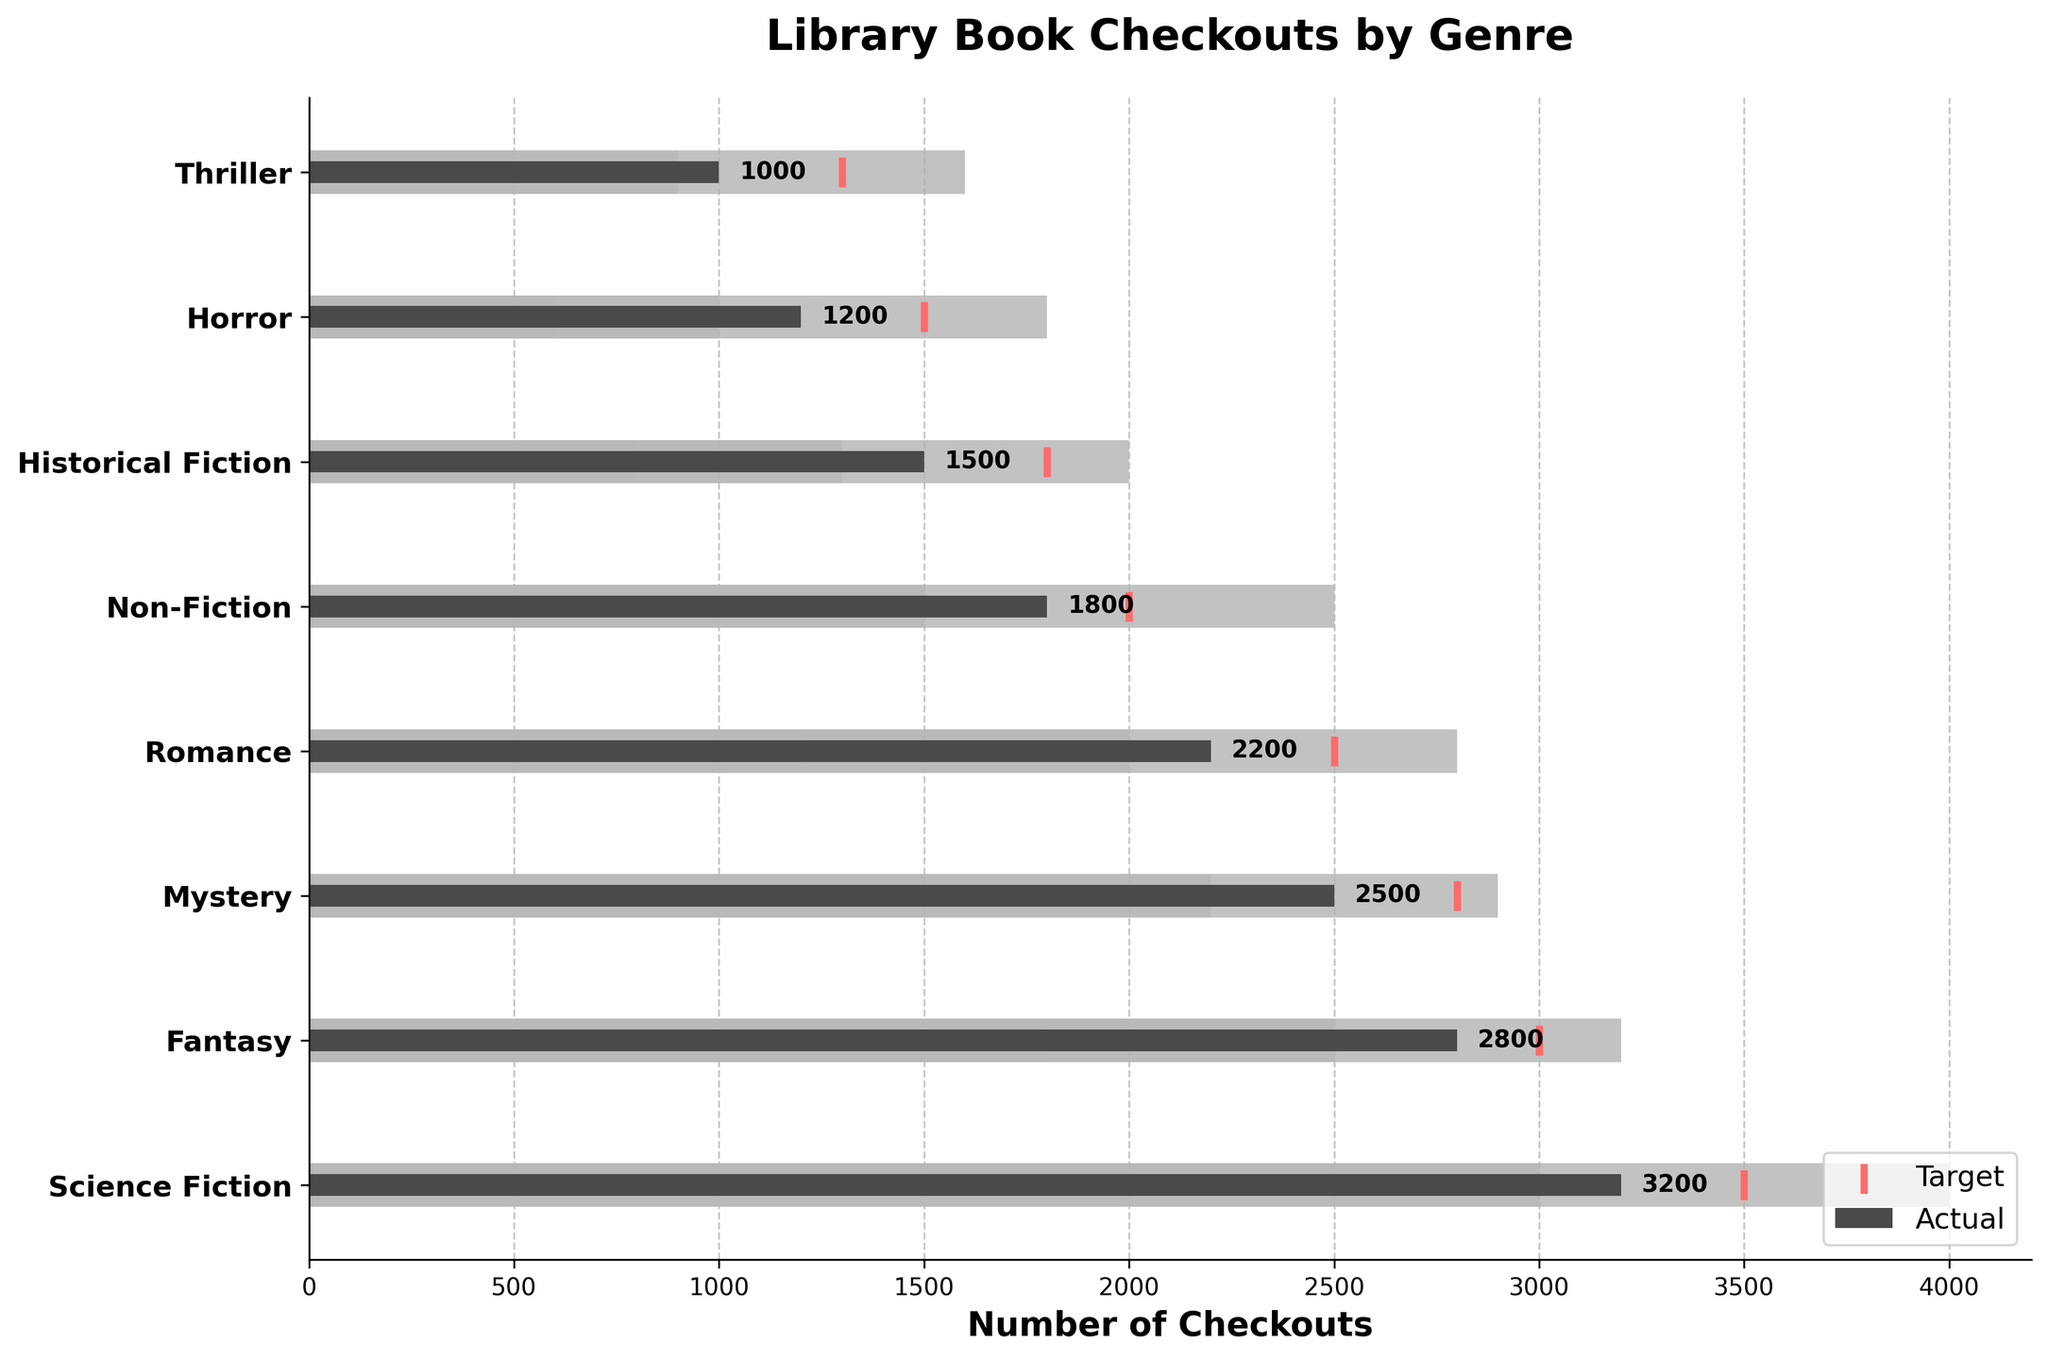What is the title of the figure? The title of the figure is located at the top and describes the main subject of the chart.
Answer: Library Book Checkouts by Genre Which genre has the highest number of actual checkouts? By observing the length of the dark bars representing actual values, we see that the "Science Fiction" genre has the longest bar.
Answer: Science Fiction What is the target value for Science Fiction checkouts? The target values are represented by the vertical red lines. By locating the target line for "Science Fiction," we see the value.
Answer: 3500 Which genre has the lowest number of actual checkouts? By looking at the length of the dark bars, we notice that the "Thriller" genre has the shortest bar.
Answer: Thriller Did any genre meet their target checkouts? To determine this, compare the end of the dark bar (actual) to the red line (target) for each genre. None of the dark bars reach or exceed the red lines.
Answer: No What is the difference between the actual and target checkouts for Fantasy? Identify the actual and target values for Fantasy and subtract the actual from the target (3000 - 2800).
Answer: 200 How many genres have more than 2500 actual checkouts? Count the number of genres where the dark bar's length exceeds the 2500 mark on the x-axis. Only "Science Fiction" and "Fantasy" exceed this mark.
Answer: 2 Which genres fall within their expected range (Range3)? Compare the actual value to the three range bands for each genre. If the actual value is less than or equal to Range3, it falls within the range. All genres fall within their Range3 values.
Answer: All genres How much did the actual checkouts of Romance fall short of their target? Subtract the actual checkouts from the target for Romance (2500 - 2200).
Answer: 300 Compare the actual checkouts of Historical Fiction and Horror. Which one is higher and by how much? Identify the actual values for Historical Fiction (1500) and Horror (1200) and subtract the smaller value from the larger value (1500 - 1200).
Answer: Historical Fiction by 300 